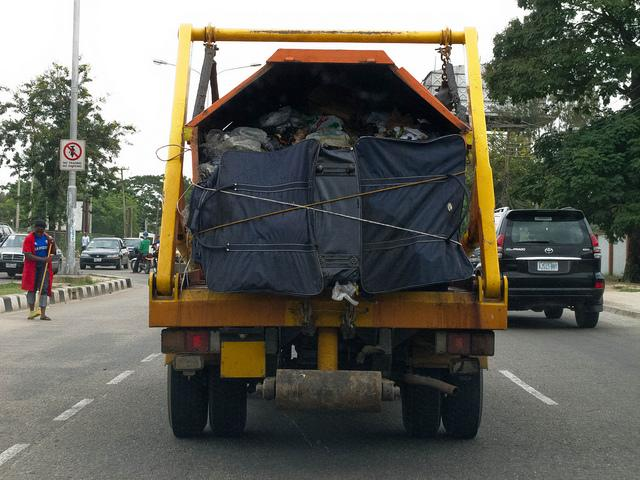Where might the truck in yellow be headed? dump 